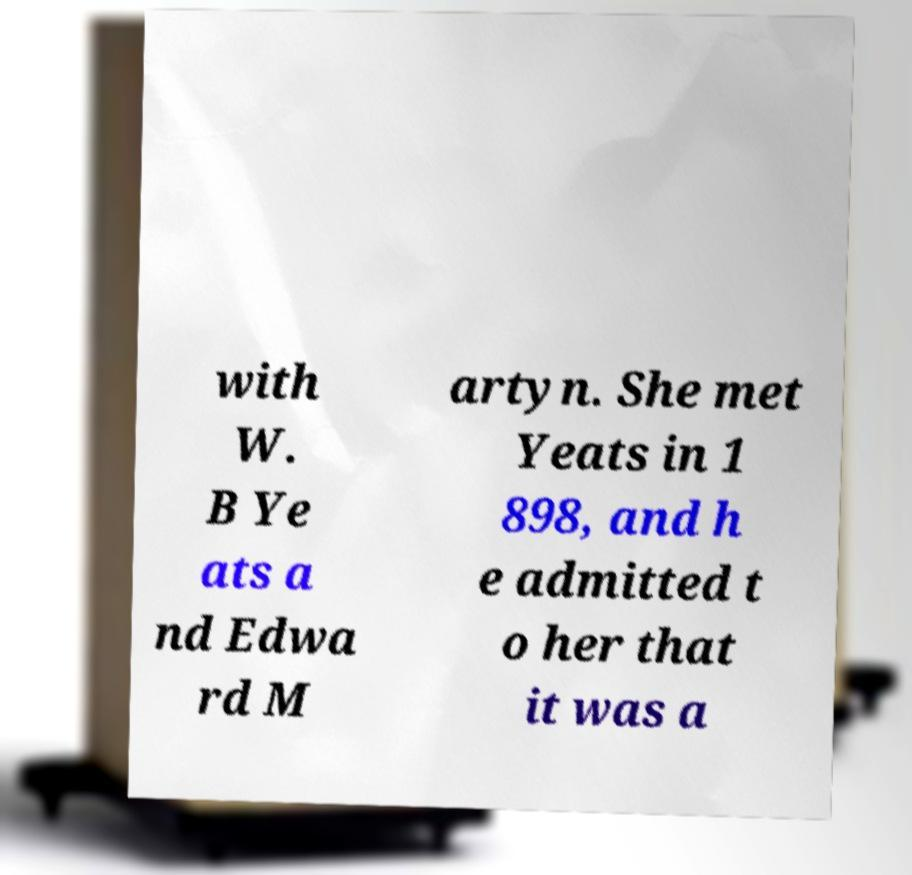There's text embedded in this image that I need extracted. Can you transcribe it verbatim? with W. B Ye ats a nd Edwa rd M artyn. She met Yeats in 1 898, and h e admitted t o her that it was a 